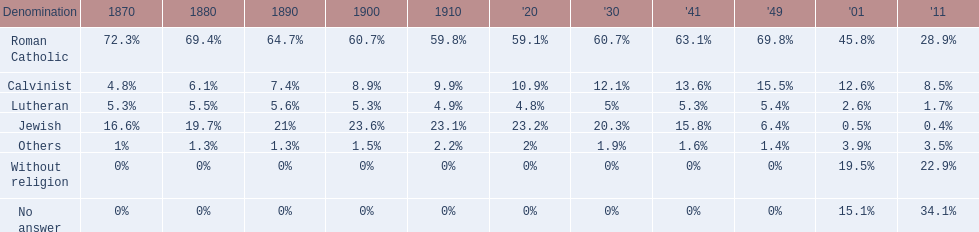Which denomination held the largest percentage in 1880? Roman Catholic. 